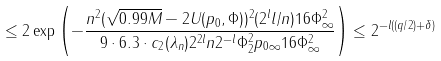<formula> <loc_0><loc_0><loc_500><loc_500>\leq 2 \exp \left ( - \frac { n ^ { 2 } ( \sqrt { 0 . 9 9 M } - 2 U ( p _ { 0 } , \Phi ) ) ^ { 2 } ( 2 ^ { l } l / n ) 1 6 \| \Phi \| _ { \infty } ^ { 2 } } { 9 \cdot 6 . 3 \cdot c _ { 2 } ( \lambda _ { n } ) 2 ^ { 2 l } n 2 ^ { - l } \| \Phi \| _ { 2 } ^ { 2 } \| p _ { 0 } \| _ { \infty } 1 6 \| \Phi \| _ { \infty } ^ { 2 } } \right ) \leq 2 ^ { - l ( ( q / 2 ) + \delta ) }</formula> 